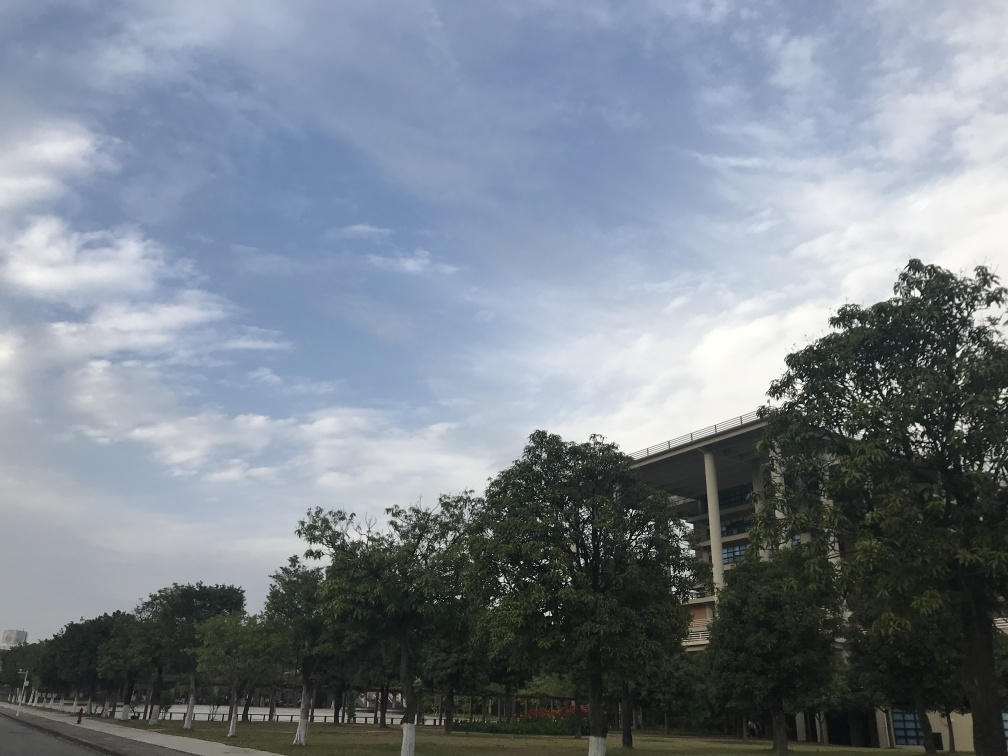What time of day does it appear to be in this image? Considering the brightness of the sky and the length of the shadows cast by the trees, it suggests the photo was taken in the late afternoon when the sun is transitioning towards the horizon. 